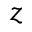Convert formula to latex. <formula><loc_0><loc_0><loc_500><loc_500>z</formula> 